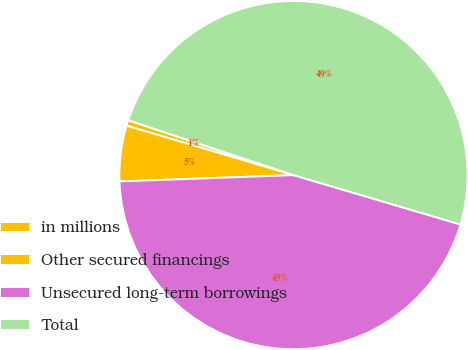Convert chart. <chart><loc_0><loc_0><loc_500><loc_500><pie_chart><fcel>in millions<fcel>Other secured financings<fcel>Unsecured long-term borrowings<fcel>Total<nl><fcel>0.52%<fcel>5.16%<fcel>44.84%<fcel>49.48%<nl></chart> 